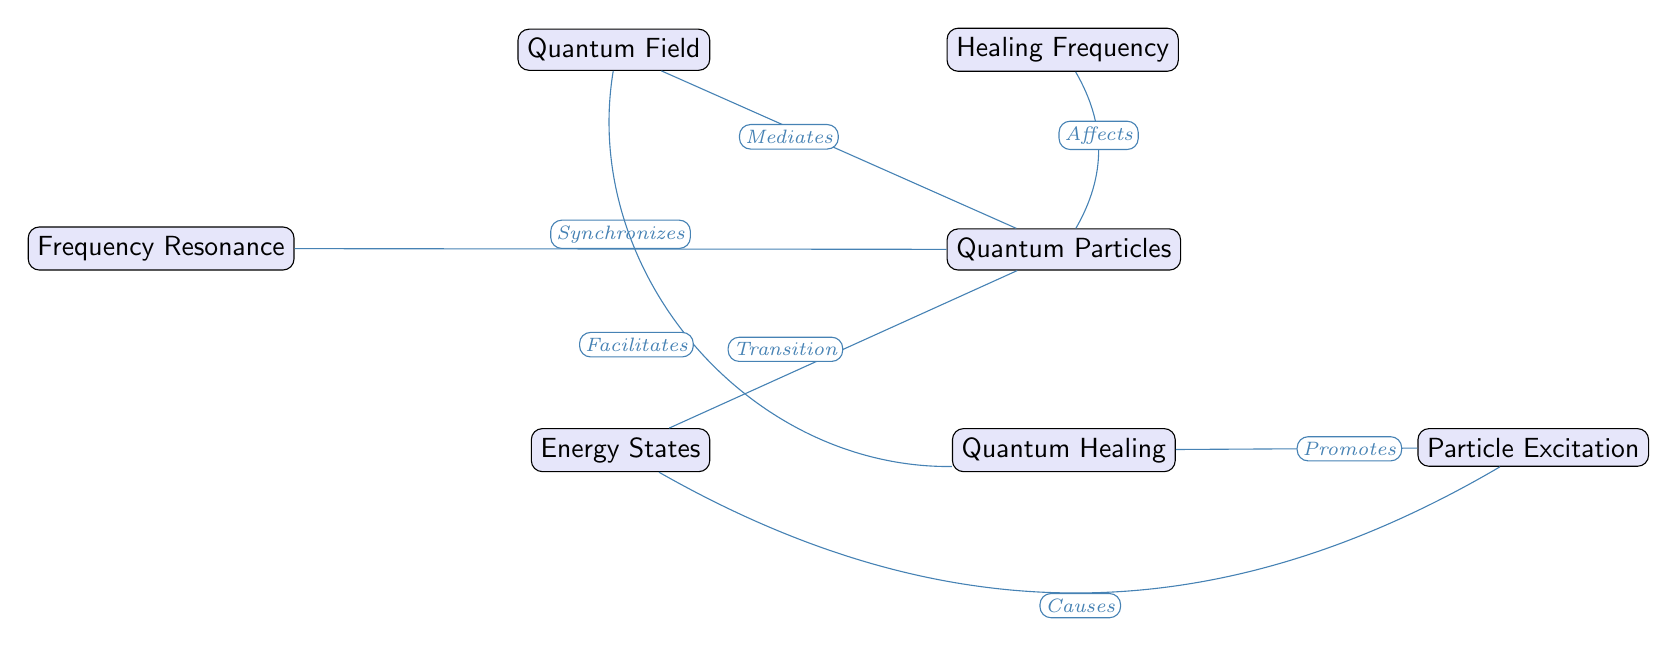What is the central node in the diagram? The diagram's central node is the "Quantum Field," as it is positioned at the top and connects with multiple other nodes, indicating its primary role in the overall system.
Answer: Quantum Field How many nodes are present in the diagram? By counting all the distinct nodes, we find there are six nodes in total: Quantum Field, Healing Frequency, Quantum Particles, Energy States, Frequency Resonance, Particle Excitation, and Quantum Healing.
Answer: 7 What does the "Healing Frequency" affect? The diagram indicates that the "Healing Frequency" affects "Quantum Particles," as shown by the directed edge labeled "Affects" that connects these two nodes.
Answer: Quantum Particles What is "Frequency Resonance" related to? According to the diagram, "Frequency Resonance" synchronizes with "Quantum Particles," as indicated by the direct edge connecting these nodes with the label "Synchronizes."
Answer: Quantum Particles What causes "Particle Excitation"? The diagram states that "Energy States" causes "Particle Excitation," reflected by the edge labeled "Causes" that flows from "Energy States" to "Particle Excitation."
Answer: Energy States How does "Quantum Field" facilitate "Quantum Healing"? The diagram shows that the "Quantum Field" facilitates "Quantum Healing" with an edge labeled "Facilitates," indicating a direct relationship where the Quantum Field influences the process of Quantum Healing.
Answer: Quantum Healing Which node is directly influenced by "Particle Excitation"? The diagram indicates that "Quantum Healing" is directly promoted by "Particle Excitation," as denoted by the edge labeled "Promotes." Thus, "Quantum Healing" is the node influenced directly by "Particle Excitation."
Answer: Quantum Healing What role does "Quantum Field" play in relation to "Quantum Particles"? In the diagram, the "Quantum Field" mediates the behavior of "Quantum Particles," as illustrated by the edge labeled "Mediates," showing a key influence the Quantum Field has over the particles.
Answer: Mediates 